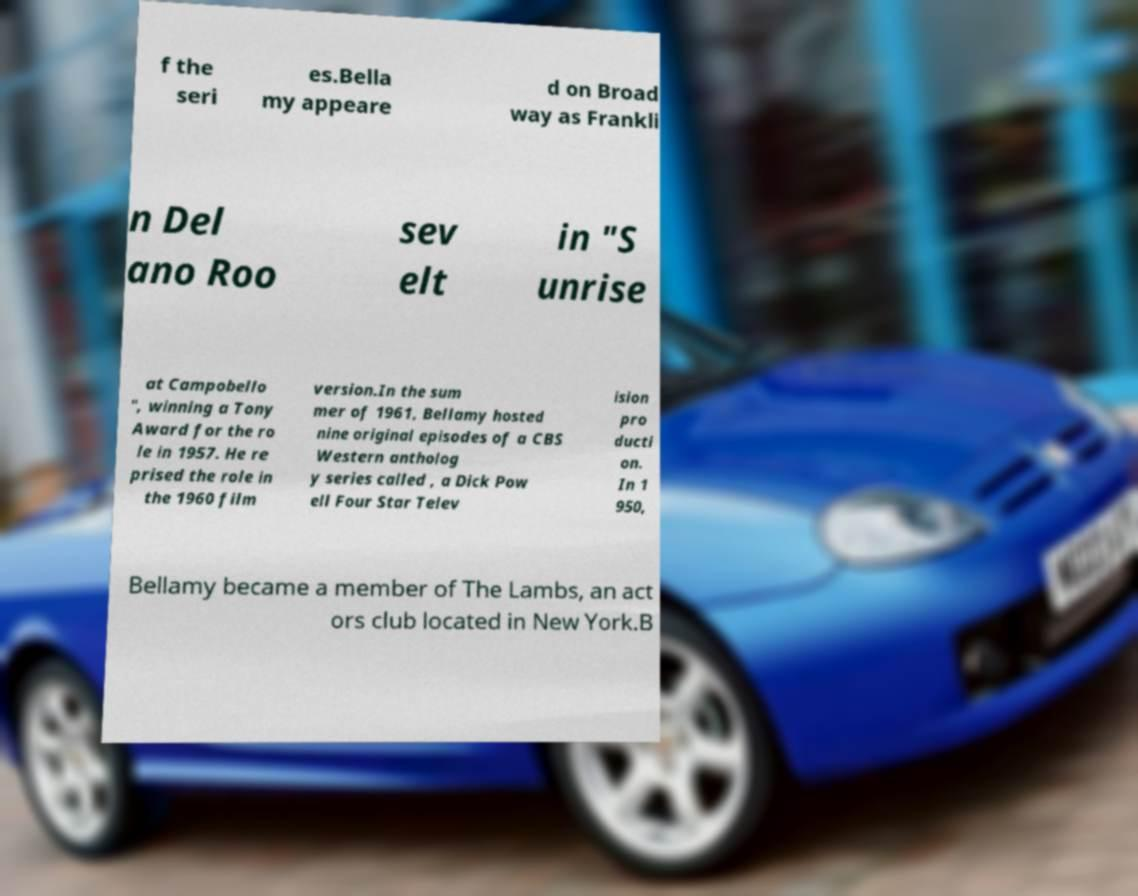Can you accurately transcribe the text from the provided image for me? f the seri es.Bella my appeare d on Broad way as Frankli n Del ano Roo sev elt in "S unrise at Campobello ", winning a Tony Award for the ro le in 1957. He re prised the role in the 1960 film version.In the sum mer of 1961, Bellamy hosted nine original episodes of a CBS Western antholog y series called , a Dick Pow ell Four Star Telev ision pro ducti on. In 1 950, Bellamy became a member of The Lambs, an act ors club located in New York.B 